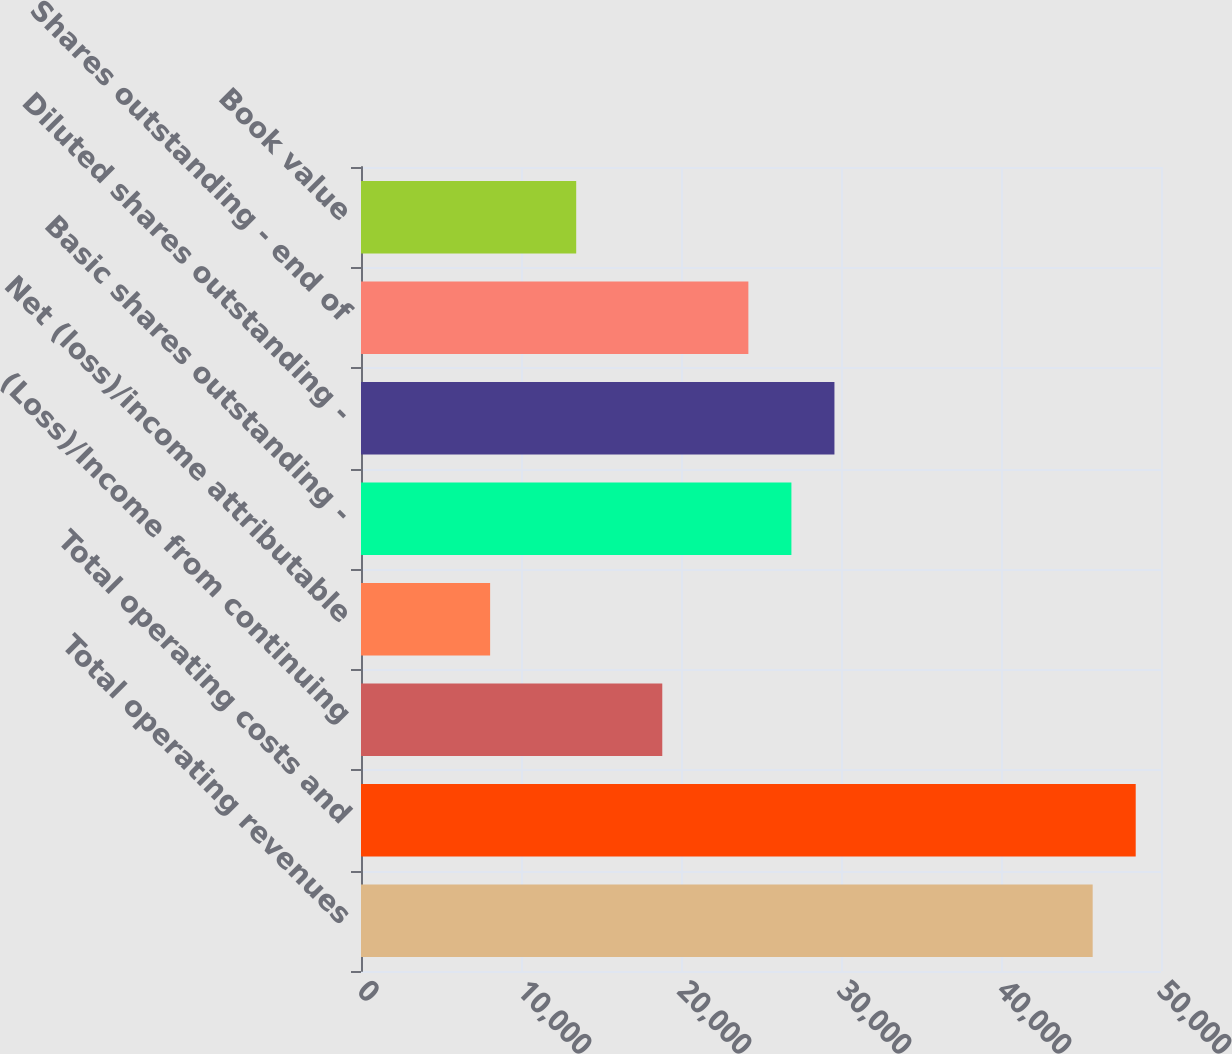Convert chart. <chart><loc_0><loc_0><loc_500><loc_500><bar_chart><fcel>Total operating revenues<fcel>Total operating costs and<fcel>(Loss)/Income from continuing<fcel>Net (loss)/income attributable<fcel>Basic shares outstanding -<fcel>Diluted shares outstanding -<fcel>Shares outstanding - end of<fcel>Book value<nl><fcel>45729.4<fcel>48419.3<fcel>18830.2<fcel>8070.52<fcel>26900<fcel>29589.9<fcel>24210<fcel>13450.4<nl></chart> 